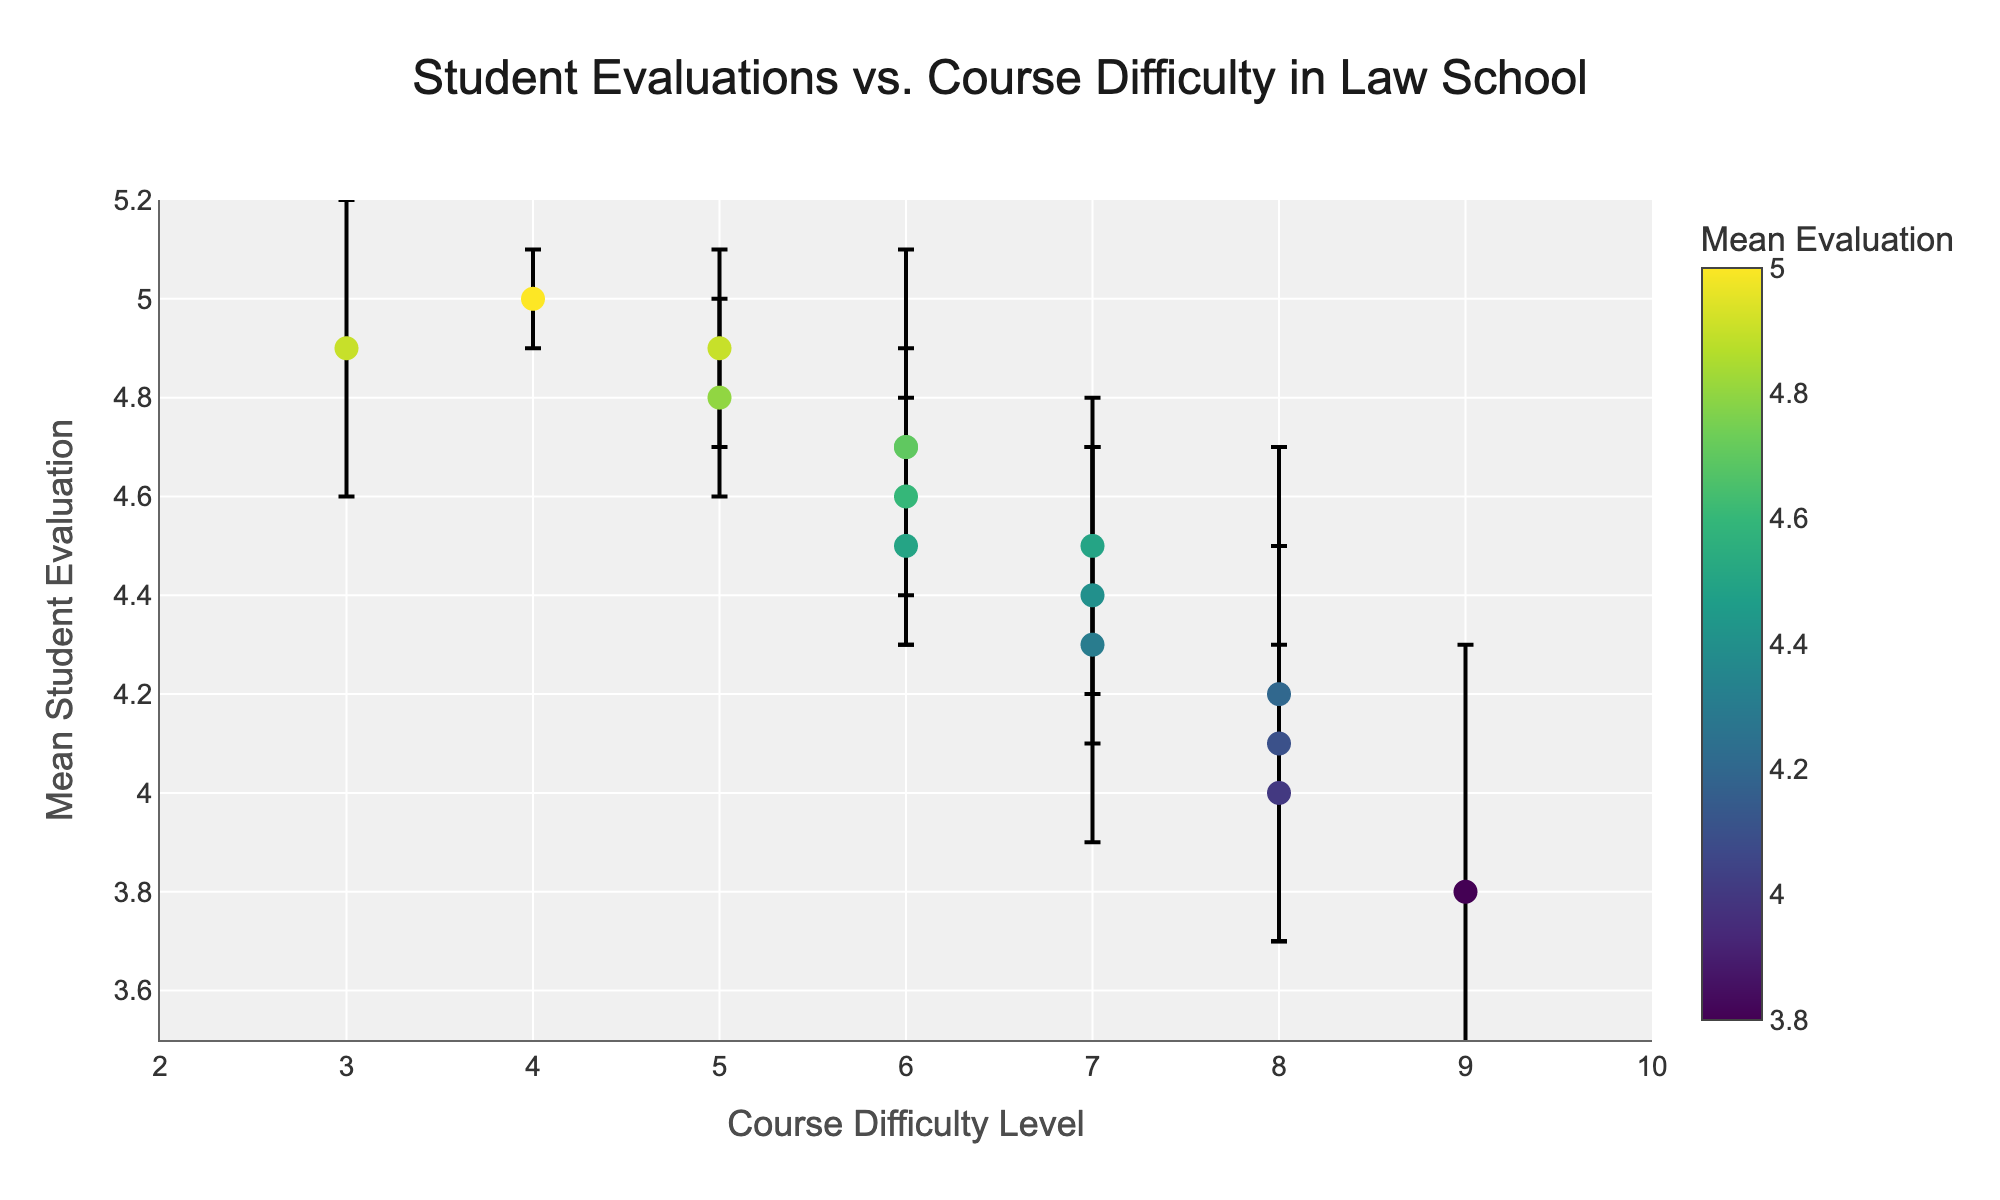What's the title of the figure? The title of the figure is at the top and indicates what the data is about. The title is "Student Evaluations vs. Course Difficulty in Law School".
Answer: Student Evaluations vs. Course Difficulty in Law School What does the color bar represent? The color bar on the right of the figure indicates the range of Mean Student Evaluation scores for the courses. Darker colors on the Viridis scale correspond to higher evaluations.
Answer: Mean Student Evaluation Which course has the highest mean student evaluation? Based on the scatter plot, Legal Writing has the highest point on the y-axis, indicating the highest mean student evaluation of 5.0.
Answer: Legal Writing What is the difficulty level for Taxation? The scatter plot shows Taxation at a difficulty level of 9. This can be seen from its position on the x-axis.
Answer: 9 Are there any courses with the same difficulty level but different mean student evaluations? Courses like Environmental Law and Civil Procedure both have the same difficulty level of 8, but Environmental Law has a mean student evaluation of 4.0, and Civil Procedure has 4.2.
Answer: Yes What course has the lowest mean student evaluation, and what is its difficulty level? Taxation has the lowest mean student evaluation at 3.8, and its difficulty level is 9. This can be confirmed by checking the lowest point on the y-axis.
Answer: Taxation, 9 Which course has the largest error bar? Civil Procedure and Taxation both have the largest error bars, each with a standard error of 0.5, seen by the length of the error bars extending from these points.
Answer: Civil Procedure and Taxation What is the mean student evaluation for Constitutional Law? The point representing Constitutional Law is positioned at a y-value of 4.5, indicating its mean student evaluation.
Answer: 4.5 What is the relationship between course difficulty and variability in student evaluations? By looking at the scatter plot, there seems to be a general trend where higher difficulty courses (e.g., Taxation, International Law) have higher variability (larger error bars) in student evaluations compared to lower difficulty courses.
Answer: Higher difficulty courses tend to have higher variability in evaluations 